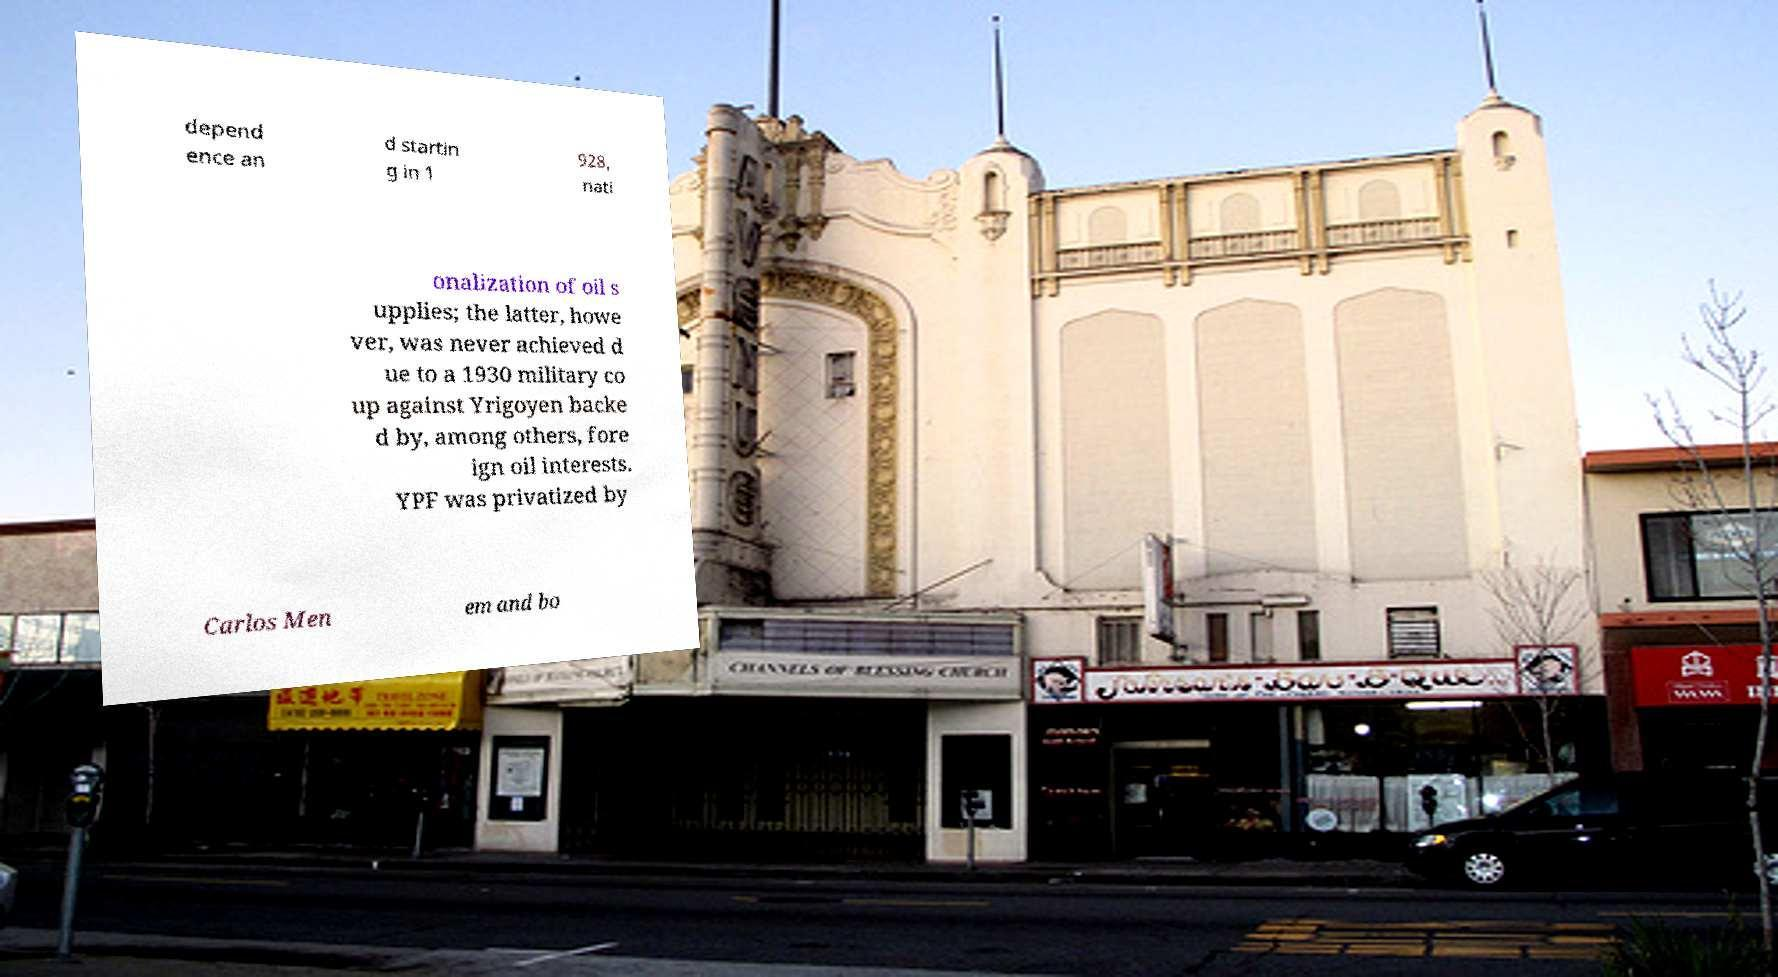Please read and relay the text visible in this image. What does it say? depend ence an d startin g in 1 928, nati onalization of oil s upplies; the latter, howe ver, was never achieved d ue to a 1930 military co up against Yrigoyen backe d by, among others, fore ign oil interests. YPF was privatized by Carlos Men em and bo 